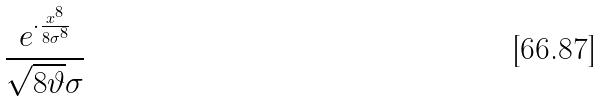<formula> <loc_0><loc_0><loc_500><loc_500>\frac { e ^ { \cdot \frac { x ^ { 8 } } { 8 \sigma ^ { 8 } } } } { \sqrt { 8 \vartheta } \sigma }</formula> 